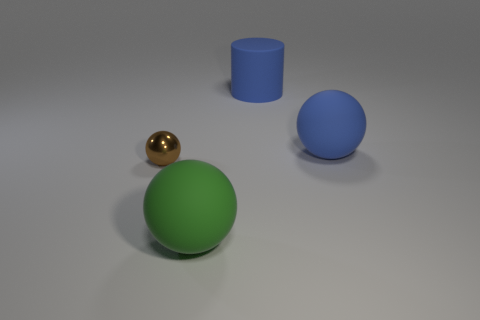Add 2 small yellow matte balls. How many objects exist? 6 Subtract all cylinders. How many objects are left? 3 Add 4 tiny gray blocks. How many tiny gray blocks exist? 4 Subtract 0 gray spheres. How many objects are left? 4 Subtract all tiny matte cylinders. Subtract all brown spheres. How many objects are left? 3 Add 3 brown metal things. How many brown metal things are left? 4 